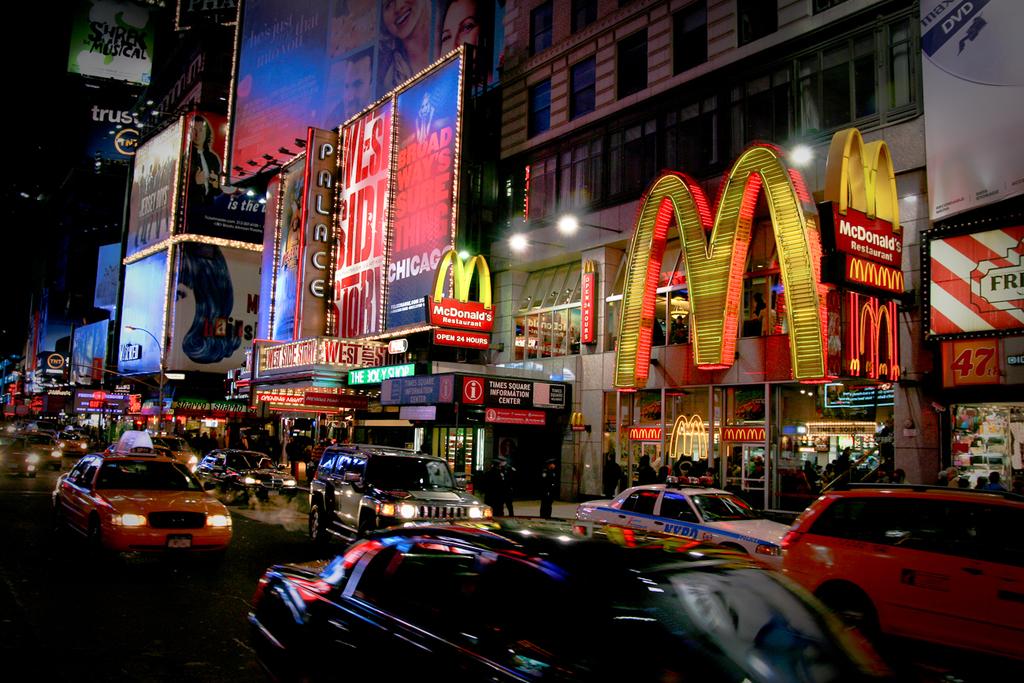What is the name of the fast food place with the giant yellow "m"?
Your response must be concise. Mcdonalds. What play is advertised to the left of mcdonald's?
Your answer should be compact. West side story. 